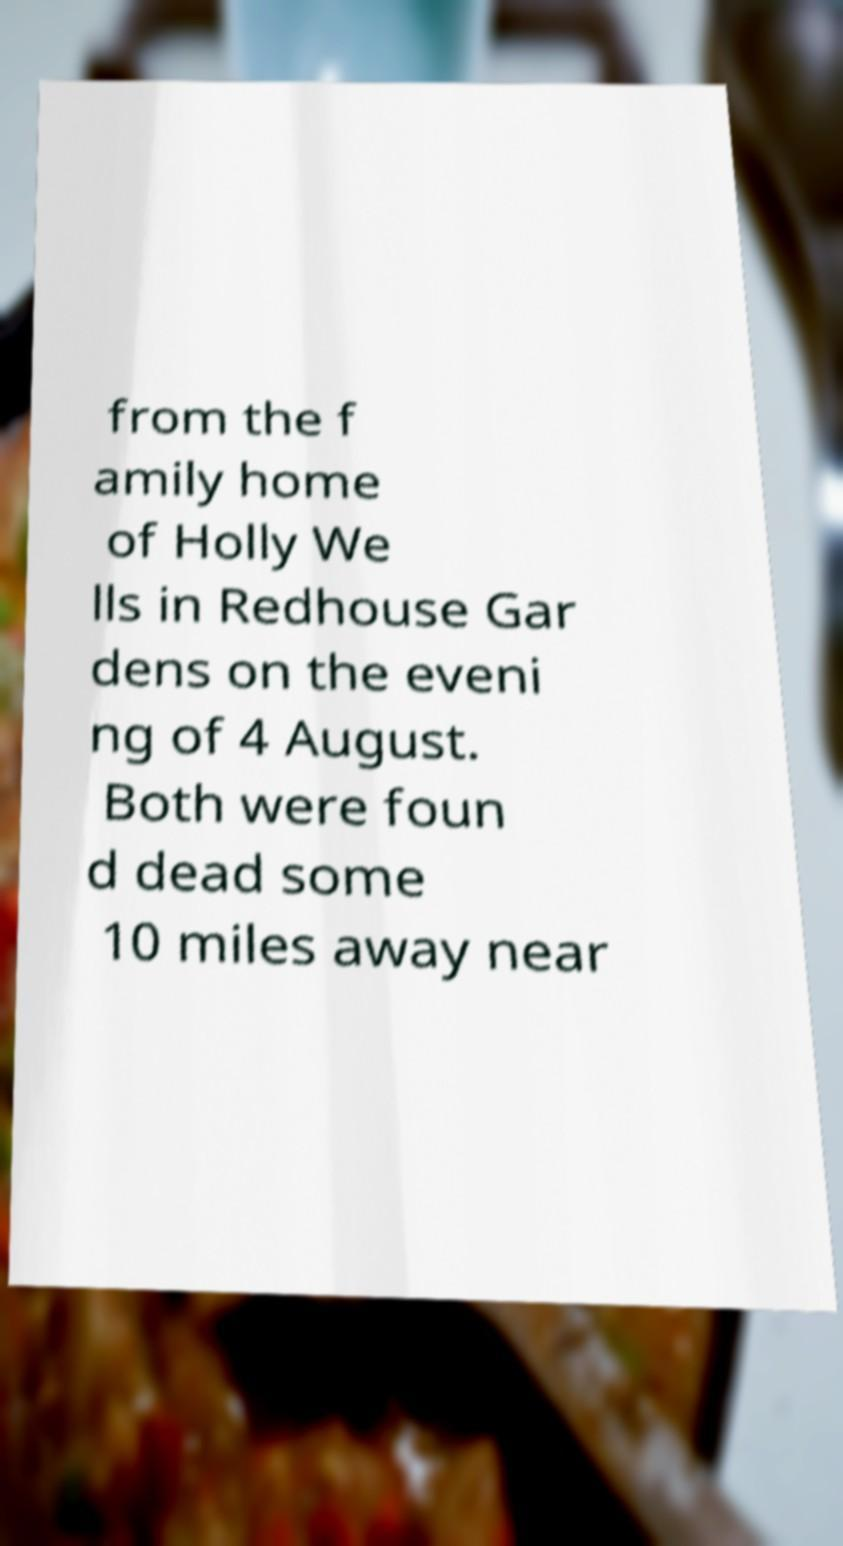For documentation purposes, I need the text within this image transcribed. Could you provide that? from the f amily home of Holly We lls in Redhouse Gar dens on the eveni ng of 4 August. Both were foun d dead some 10 miles away near 